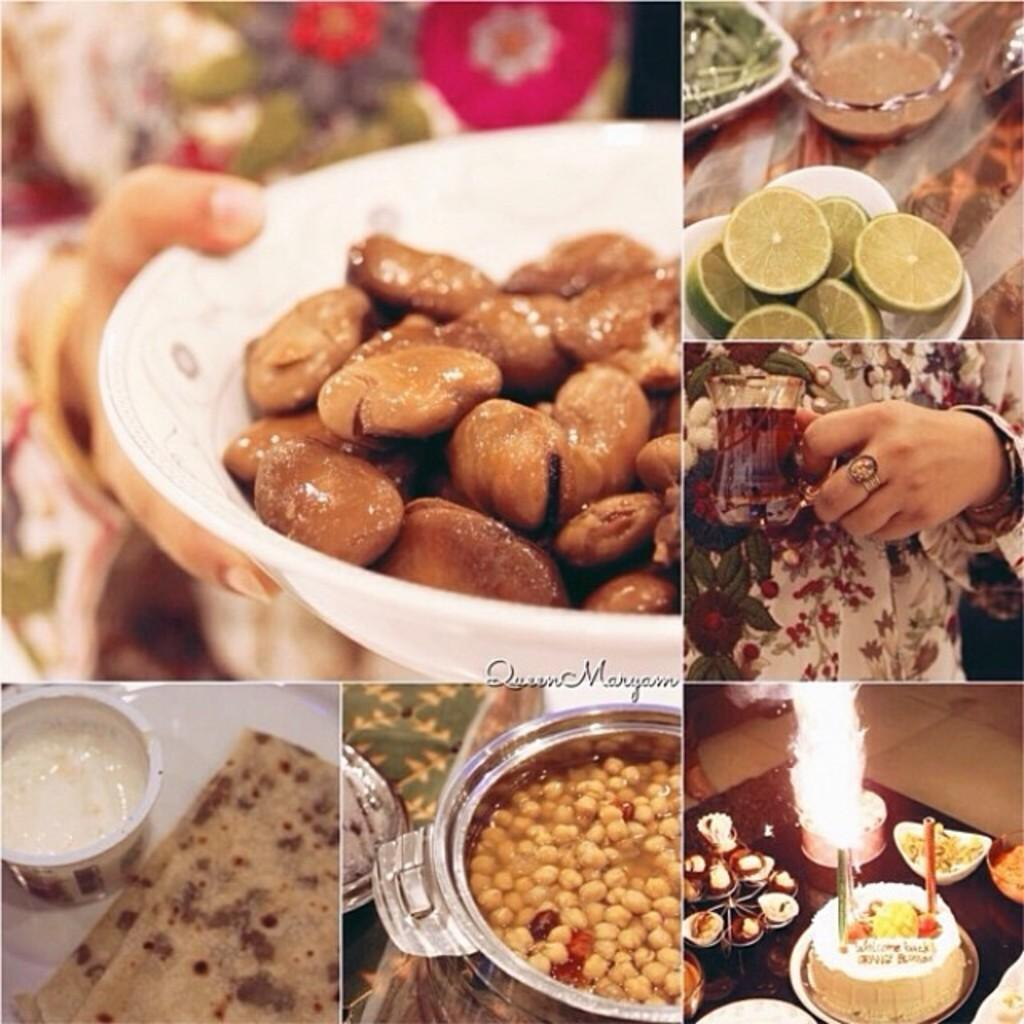What type of artwork is shown in the image? The image is a collage of different pictures. What is the common theme among the pictures in the collage? Each picture in the collage contains food items. Which actor is performing behind the curtain in the image? There is no actor or curtain present in the image. 